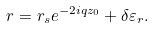Convert formula to latex. <formula><loc_0><loc_0><loc_500><loc_500>r = r _ { s } e ^ { - 2 i q z _ { 0 } } + \delta \varepsilon _ { r } .</formula> 